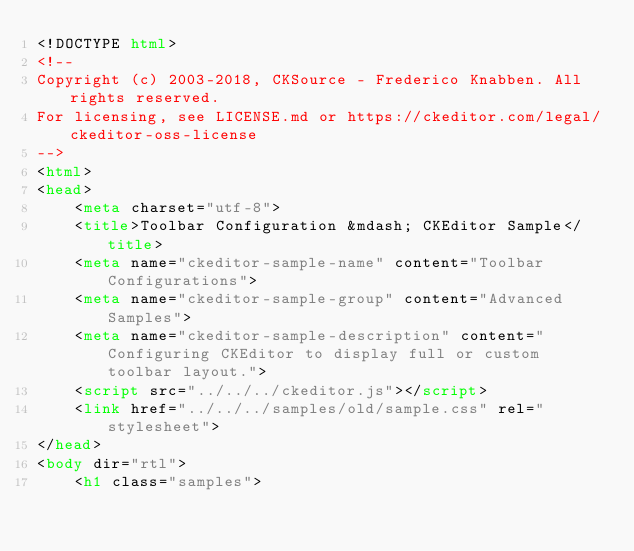<code> <loc_0><loc_0><loc_500><loc_500><_HTML_><!DOCTYPE html>
<!--
Copyright (c) 2003-2018, CKSource - Frederico Knabben. All rights reserved.
For licensing, see LICENSE.md or https://ckeditor.com/legal/ckeditor-oss-license
-->
<html>
<head>
	<meta charset="utf-8">
	<title>Toolbar Configuration &mdash; CKEditor Sample</title>
	<meta name="ckeditor-sample-name" content="Toolbar Configurations">
	<meta name="ckeditor-sample-group" content="Advanced Samples">
	<meta name="ckeditor-sample-description" content="Configuring CKEditor to display full or custom toolbar layout.">
	<script src="../../../ckeditor.js"></script>
	<link href="../../../samples/old/sample.css" rel="stylesheet">
</head>
<body dir="rtl">
	<h1 class="samples"></code> 